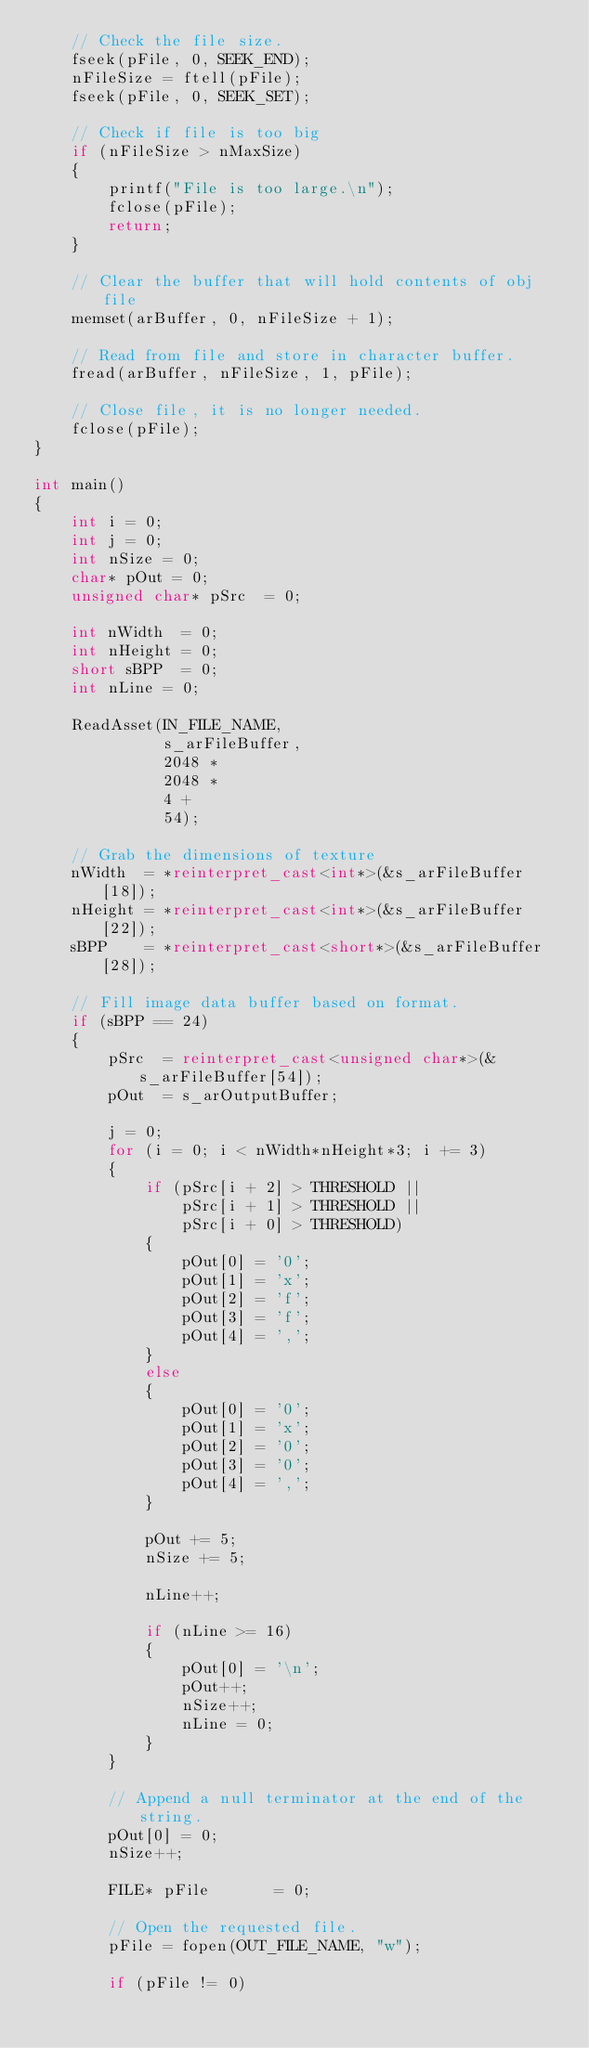Convert code to text. <code><loc_0><loc_0><loc_500><loc_500><_C++_>    // Check the file size.
    fseek(pFile, 0, SEEK_END);
    nFileSize = ftell(pFile);
    fseek(pFile, 0, SEEK_SET);

    // Check if file is too big
    if (nFileSize > nMaxSize)
    {
        printf("File is too large.\n");
        fclose(pFile);
        return;
    }

    // Clear the buffer that will hold contents of obj file
    memset(arBuffer, 0, nFileSize + 1);

    // Read from file and store in character buffer.
    fread(arBuffer, nFileSize, 1, pFile);

    // Close file, it is no longer needed.
    fclose(pFile);
}

int main()
{
    int i = 0;
    int j = 0;
    int nSize = 0;
    char* pOut = 0;
    unsigned char* pSrc  = 0;
    
    int nWidth  = 0;
    int nHeight = 0;
    short sBPP  = 0;
    int nLine = 0;

    ReadAsset(IN_FILE_NAME,
              s_arFileBuffer,
              2048 * 
              2048 *
              4 + 
              54);

    // Grab the dimensions of texture
    nWidth  = *reinterpret_cast<int*>(&s_arFileBuffer[18]);
    nHeight = *reinterpret_cast<int*>(&s_arFileBuffer[22]);
    sBPP    = *reinterpret_cast<short*>(&s_arFileBuffer[28]);

    // Fill image data buffer based on format.
    if (sBPP == 24)
    {
        pSrc  = reinterpret_cast<unsigned char*>(&s_arFileBuffer[54]);
        pOut  = s_arOutputBuffer;

        j = 0;
        for (i = 0; i < nWidth*nHeight*3; i += 3)
        {
            if (pSrc[i + 2] > THRESHOLD ||
                pSrc[i + 1] > THRESHOLD ||
                pSrc[i + 0] > THRESHOLD)
            {
                pOut[0] = '0';
                pOut[1] = 'x';
                pOut[2] = 'f';
                pOut[3] = 'f';
                pOut[4] = ',';
            }
            else
            {
                pOut[0] = '0';
                pOut[1] = 'x';
                pOut[2] = '0';
                pOut[3] = '0';
                pOut[4] = ',';
            }

            pOut += 5;
            nSize += 5;

            nLine++;

            if (nLine >= 16)
            {
                pOut[0] = '\n';
                pOut++;
                nSize++;
                nLine = 0;
            }
        }

        // Append a null terminator at the end of the string.
        pOut[0] = 0;
        nSize++;

        FILE* pFile       = 0;

        // Open the requested file.
        pFile = fopen(OUT_FILE_NAME, "w");
        
        if (pFile != 0)</code> 